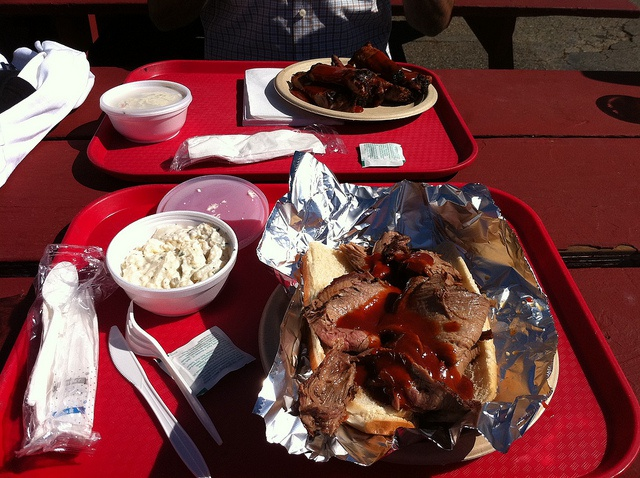Describe the objects in this image and their specific colors. I can see dining table in maroon, black, brown, and gray tones, people in maroon, black, gray, and darkgray tones, bowl in maroon, ivory, brown, darkgray, and tan tones, sandwich in maroon, brown, black, and khaki tones, and bowl in maroon, lightgray, lightpink, and brown tones in this image. 